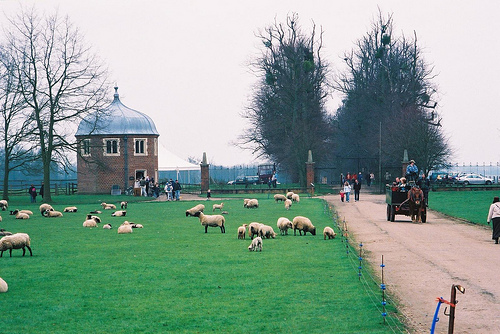How many cars are visible? There is one car visible in the image, parked on the far right. 